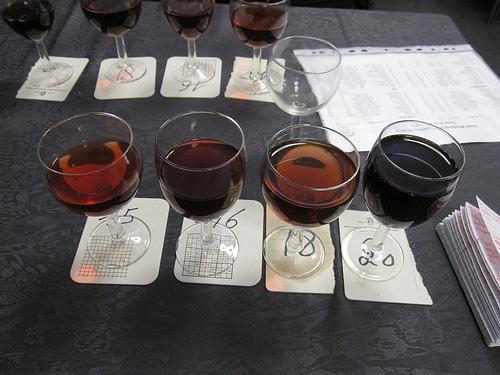How many people drinking in the picture?
Give a very brief answer. 0. How many dinosaurs are in the picture?
Give a very brief answer. 0. How many wine glasses are in the picture?
Give a very brief answer. 9. How many wine glasses are empty?
Give a very brief answer. 1. 